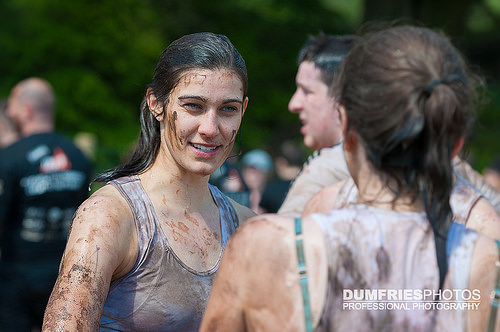<image>
Is there a woman next to the man? Yes. The woman is positioned adjacent to the man, located nearby in the same general area. 